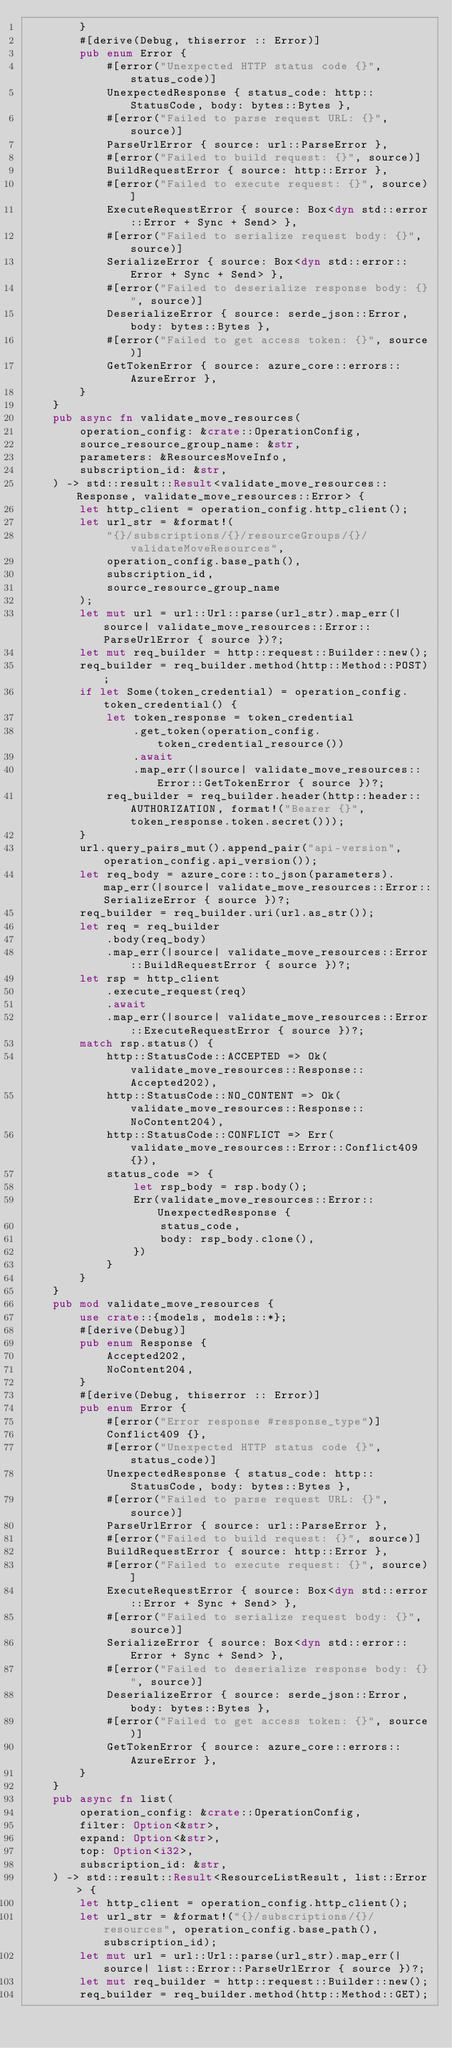<code> <loc_0><loc_0><loc_500><loc_500><_Rust_>        }
        #[derive(Debug, thiserror :: Error)]
        pub enum Error {
            #[error("Unexpected HTTP status code {}", status_code)]
            UnexpectedResponse { status_code: http::StatusCode, body: bytes::Bytes },
            #[error("Failed to parse request URL: {}", source)]
            ParseUrlError { source: url::ParseError },
            #[error("Failed to build request: {}", source)]
            BuildRequestError { source: http::Error },
            #[error("Failed to execute request: {}", source)]
            ExecuteRequestError { source: Box<dyn std::error::Error + Sync + Send> },
            #[error("Failed to serialize request body: {}", source)]
            SerializeError { source: Box<dyn std::error::Error + Sync + Send> },
            #[error("Failed to deserialize response body: {}", source)]
            DeserializeError { source: serde_json::Error, body: bytes::Bytes },
            #[error("Failed to get access token: {}", source)]
            GetTokenError { source: azure_core::errors::AzureError },
        }
    }
    pub async fn validate_move_resources(
        operation_config: &crate::OperationConfig,
        source_resource_group_name: &str,
        parameters: &ResourcesMoveInfo,
        subscription_id: &str,
    ) -> std::result::Result<validate_move_resources::Response, validate_move_resources::Error> {
        let http_client = operation_config.http_client();
        let url_str = &format!(
            "{}/subscriptions/{}/resourceGroups/{}/validateMoveResources",
            operation_config.base_path(),
            subscription_id,
            source_resource_group_name
        );
        let mut url = url::Url::parse(url_str).map_err(|source| validate_move_resources::Error::ParseUrlError { source })?;
        let mut req_builder = http::request::Builder::new();
        req_builder = req_builder.method(http::Method::POST);
        if let Some(token_credential) = operation_config.token_credential() {
            let token_response = token_credential
                .get_token(operation_config.token_credential_resource())
                .await
                .map_err(|source| validate_move_resources::Error::GetTokenError { source })?;
            req_builder = req_builder.header(http::header::AUTHORIZATION, format!("Bearer {}", token_response.token.secret()));
        }
        url.query_pairs_mut().append_pair("api-version", operation_config.api_version());
        let req_body = azure_core::to_json(parameters).map_err(|source| validate_move_resources::Error::SerializeError { source })?;
        req_builder = req_builder.uri(url.as_str());
        let req = req_builder
            .body(req_body)
            .map_err(|source| validate_move_resources::Error::BuildRequestError { source })?;
        let rsp = http_client
            .execute_request(req)
            .await
            .map_err(|source| validate_move_resources::Error::ExecuteRequestError { source })?;
        match rsp.status() {
            http::StatusCode::ACCEPTED => Ok(validate_move_resources::Response::Accepted202),
            http::StatusCode::NO_CONTENT => Ok(validate_move_resources::Response::NoContent204),
            http::StatusCode::CONFLICT => Err(validate_move_resources::Error::Conflict409 {}),
            status_code => {
                let rsp_body = rsp.body();
                Err(validate_move_resources::Error::UnexpectedResponse {
                    status_code,
                    body: rsp_body.clone(),
                })
            }
        }
    }
    pub mod validate_move_resources {
        use crate::{models, models::*};
        #[derive(Debug)]
        pub enum Response {
            Accepted202,
            NoContent204,
        }
        #[derive(Debug, thiserror :: Error)]
        pub enum Error {
            #[error("Error response #response_type")]
            Conflict409 {},
            #[error("Unexpected HTTP status code {}", status_code)]
            UnexpectedResponse { status_code: http::StatusCode, body: bytes::Bytes },
            #[error("Failed to parse request URL: {}", source)]
            ParseUrlError { source: url::ParseError },
            #[error("Failed to build request: {}", source)]
            BuildRequestError { source: http::Error },
            #[error("Failed to execute request: {}", source)]
            ExecuteRequestError { source: Box<dyn std::error::Error + Sync + Send> },
            #[error("Failed to serialize request body: {}", source)]
            SerializeError { source: Box<dyn std::error::Error + Sync + Send> },
            #[error("Failed to deserialize response body: {}", source)]
            DeserializeError { source: serde_json::Error, body: bytes::Bytes },
            #[error("Failed to get access token: {}", source)]
            GetTokenError { source: azure_core::errors::AzureError },
        }
    }
    pub async fn list(
        operation_config: &crate::OperationConfig,
        filter: Option<&str>,
        expand: Option<&str>,
        top: Option<i32>,
        subscription_id: &str,
    ) -> std::result::Result<ResourceListResult, list::Error> {
        let http_client = operation_config.http_client();
        let url_str = &format!("{}/subscriptions/{}/resources", operation_config.base_path(), subscription_id);
        let mut url = url::Url::parse(url_str).map_err(|source| list::Error::ParseUrlError { source })?;
        let mut req_builder = http::request::Builder::new();
        req_builder = req_builder.method(http::Method::GET);</code> 